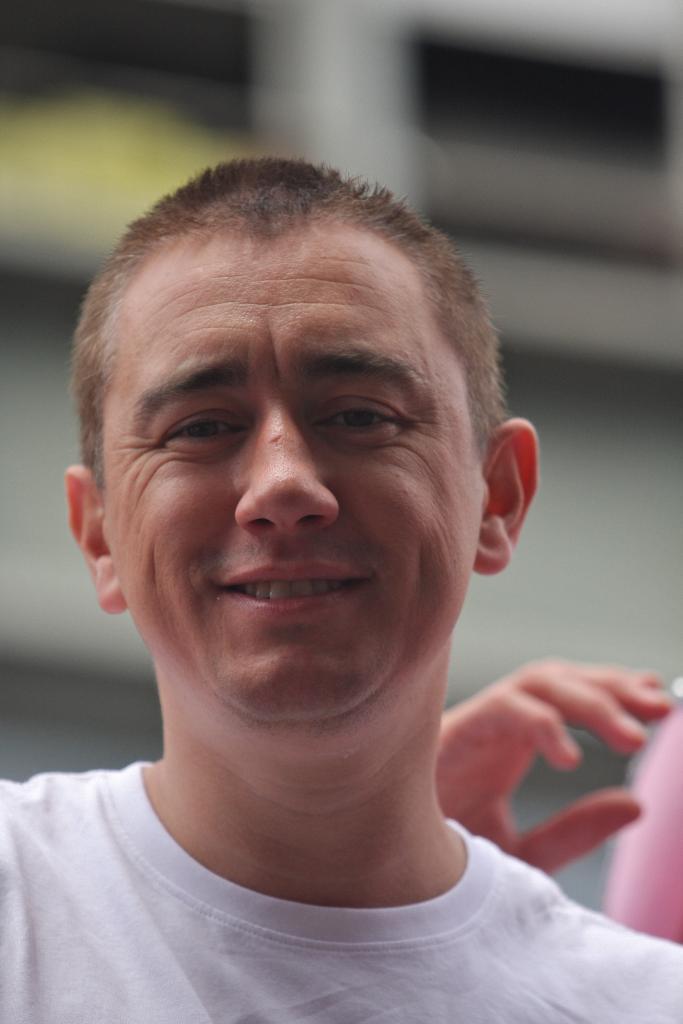How would you summarize this image in a sentence or two? In this image we can see a man. On the backside we can see the hand of a person. 